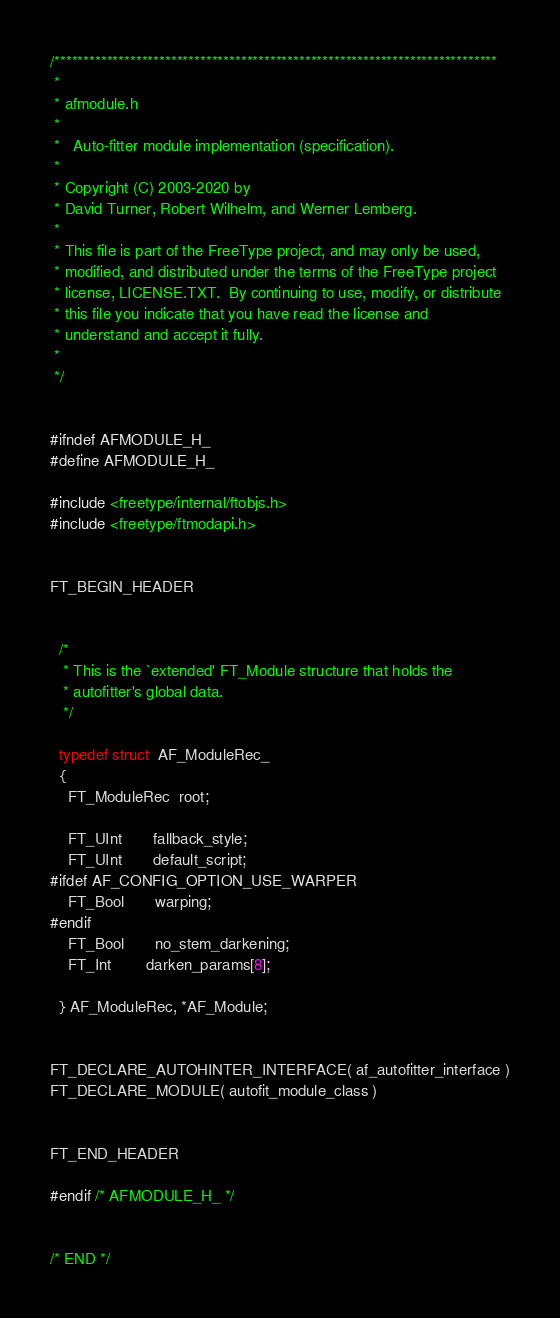<code> <loc_0><loc_0><loc_500><loc_500><_C_>/****************************************************************************
 *
 * afmodule.h
 *
 *   Auto-fitter module implementation (specification).
 *
 * Copyright (C) 2003-2020 by
 * David Turner, Robert Wilhelm, and Werner Lemberg.
 *
 * This file is part of the FreeType project, and may only be used,
 * modified, and distributed under the terms of the FreeType project
 * license, LICENSE.TXT.  By continuing to use, modify, or distribute
 * this file you indicate that you have read the license and
 * understand and accept it fully.
 *
 */


#ifndef AFMODULE_H_
#define AFMODULE_H_

#include <freetype/internal/ftobjs.h>
#include <freetype/ftmodapi.h>


FT_BEGIN_HEADER


  /*
   * This is the `extended' FT_Module structure that holds the
   * autofitter's global data.
   */

  typedef struct  AF_ModuleRec_
  {
    FT_ModuleRec  root;

    FT_UInt       fallback_style;
    FT_UInt       default_script;
#ifdef AF_CONFIG_OPTION_USE_WARPER
    FT_Bool       warping;
#endif
    FT_Bool       no_stem_darkening;
    FT_Int        darken_params[8];

  } AF_ModuleRec, *AF_Module;


FT_DECLARE_AUTOHINTER_INTERFACE( af_autofitter_interface )
FT_DECLARE_MODULE( autofit_module_class )


FT_END_HEADER

#endif /* AFMODULE_H_ */


/* END */
</code> 